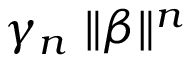<formula> <loc_0><loc_0><loc_500><loc_500>\gamma _ { n } \| \boldsymbol \beta \| ^ { n }</formula> 